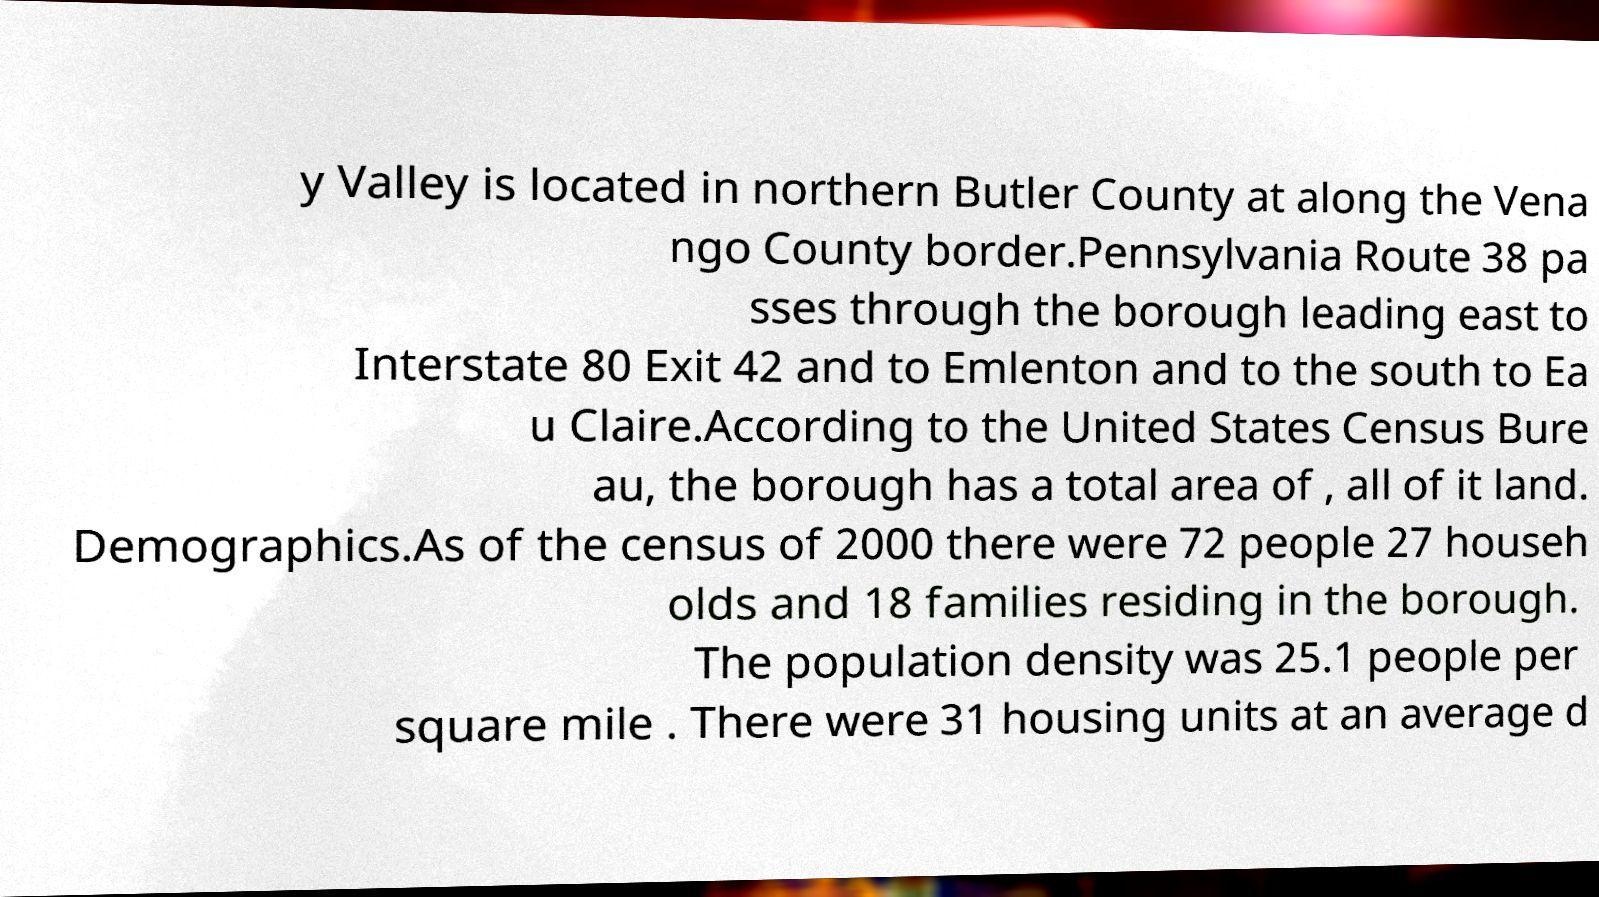Can you read and provide the text displayed in the image?This photo seems to have some interesting text. Can you extract and type it out for me? y Valley is located in northern Butler County at along the Vena ngo County border.Pennsylvania Route 38 pa sses through the borough leading east to Interstate 80 Exit 42 and to Emlenton and to the south to Ea u Claire.According to the United States Census Bure au, the borough has a total area of , all of it land. Demographics.As of the census of 2000 there were 72 people 27 househ olds and 18 families residing in the borough. The population density was 25.1 people per square mile . There were 31 housing units at an average d 